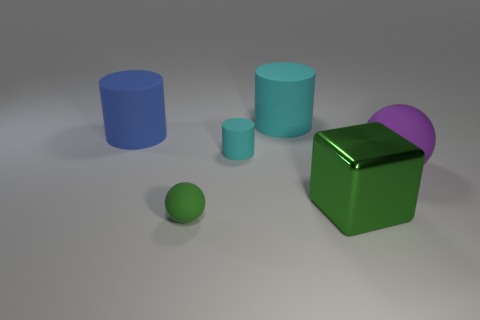Subtract all yellow balls. How many cyan cylinders are left? 2 Subtract all large cylinders. How many cylinders are left? 1 Add 2 green rubber things. How many objects exist? 8 Subtract all spheres. How many objects are left? 4 Subtract all small balls. Subtract all tiny cyan rubber cylinders. How many objects are left? 4 Add 1 large cyan matte things. How many large cyan matte things are left? 2 Add 2 tiny green matte balls. How many tiny green matte balls exist? 3 Subtract 0 gray balls. How many objects are left? 6 